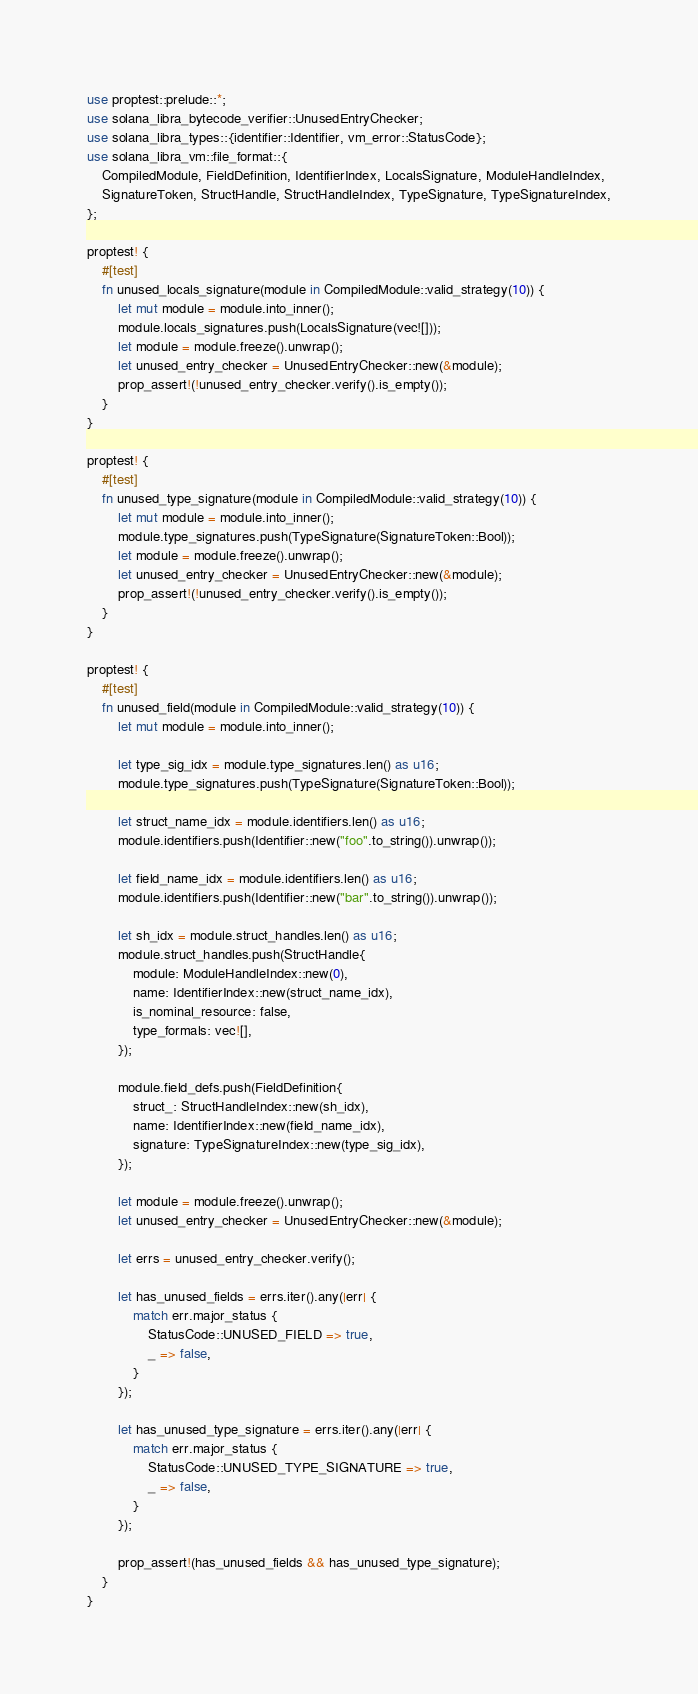<code> <loc_0><loc_0><loc_500><loc_500><_Rust_>use proptest::prelude::*;
use solana_libra_bytecode_verifier::UnusedEntryChecker;
use solana_libra_types::{identifier::Identifier, vm_error::StatusCode};
use solana_libra_vm::file_format::{
    CompiledModule, FieldDefinition, IdentifierIndex, LocalsSignature, ModuleHandleIndex,
    SignatureToken, StructHandle, StructHandleIndex, TypeSignature, TypeSignatureIndex,
};

proptest! {
    #[test]
    fn unused_locals_signature(module in CompiledModule::valid_strategy(10)) {
        let mut module = module.into_inner();
        module.locals_signatures.push(LocalsSignature(vec![]));
        let module = module.freeze().unwrap();
        let unused_entry_checker = UnusedEntryChecker::new(&module);
        prop_assert!(!unused_entry_checker.verify().is_empty());
    }
}

proptest! {
    #[test]
    fn unused_type_signature(module in CompiledModule::valid_strategy(10)) {
        let mut module = module.into_inner();
        module.type_signatures.push(TypeSignature(SignatureToken::Bool));
        let module = module.freeze().unwrap();
        let unused_entry_checker = UnusedEntryChecker::new(&module);
        prop_assert!(!unused_entry_checker.verify().is_empty());
    }
}

proptest! {
    #[test]
    fn unused_field(module in CompiledModule::valid_strategy(10)) {
        let mut module = module.into_inner();

        let type_sig_idx = module.type_signatures.len() as u16;
        module.type_signatures.push(TypeSignature(SignatureToken::Bool));

        let struct_name_idx = module.identifiers.len() as u16;
        module.identifiers.push(Identifier::new("foo".to_string()).unwrap());

        let field_name_idx = module.identifiers.len() as u16;
        module.identifiers.push(Identifier::new("bar".to_string()).unwrap());

        let sh_idx = module.struct_handles.len() as u16;
        module.struct_handles.push(StructHandle{
            module: ModuleHandleIndex::new(0),
            name: IdentifierIndex::new(struct_name_idx),
            is_nominal_resource: false,
            type_formals: vec![],
        });

        module.field_defs.push(FieldDefinition{
            struct_: StructHandleIndex::new(sh_idx),
            name: IdentifierIndex::new(field_name_idx),
            signature: TypeSignatureIndex::new(type_sig_idx),
        });

        let module = module.freeze().unwrap();
        let unused_entry_checker = UnusedEntryChecker::new(&module);

        let errs = unused_entry_checker.verify();

        let has_unused_fields = errs.iter().any(|err| {
            match err.major_status {
                StatusCode::UNUSED_FIELD => true,
                _ => false,
            }
        });

        let has_unused_type_signature = errs.iter().any(|err| {
            match err.major_status {
                StatusCode::UNUSED_TYPE_SIGNATURE => true,
                _ => false,
            }
        });

        prop_assert!(has_unused_fields && has_unused_type_signature);
    }
}
</code> 